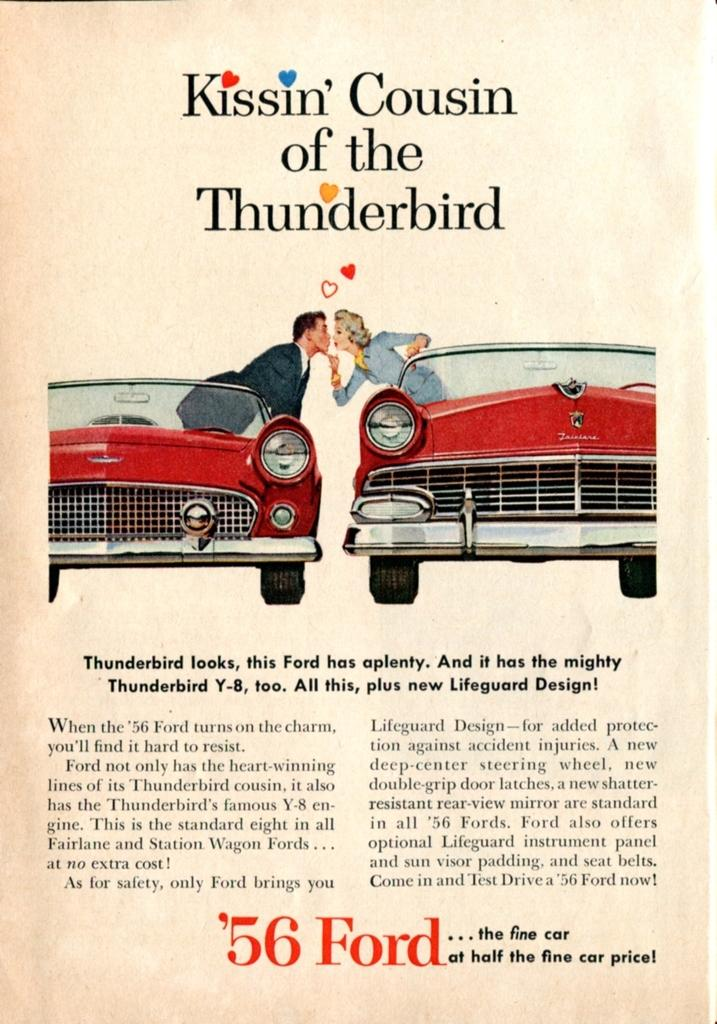What type of image is being described? The image is a poster. What is happening in the depicted scene on the poster? There are depictions of people standing in a car. Is there any text present on the poster? Yes, there is text on the image. Where is the porter standing in the image? There is no porter present in the image; it features people standing in a car. What is the name of the place depicted in the image? The image does not depict a specific place; it is a scene of people standing in a car. 